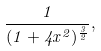<formula> <loc_0><loc_0><loc_500><loc_500>\frac { 1 } { ( 1 + 4 x ^ { 2 } ) ^ { \frac { 3 } { 2 } } } ,</formula> 